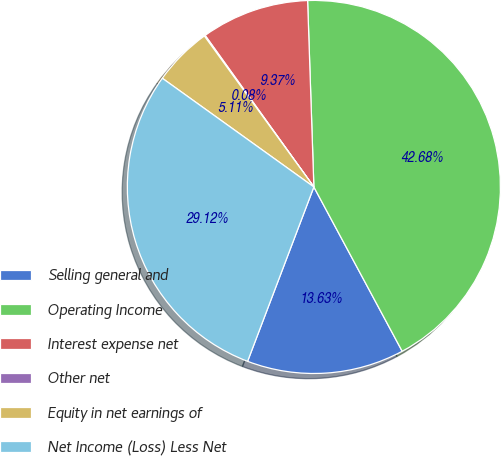Convert chart to OTSL. <chart><loc_0><loc_0><loc_500><loc_500><pie_chart><fcel>Selling general and<fcel>Operating Income<fcel>Interest expense net<fcel>Other net<fcel>Equity in net earnings of<fcel>Net Income (Loss) Less Net<nl><fcel>13.63%<fcel>42.68%<fcel>9.37%<fcel>0.08%<fcel>5.11%<fcel>29.12%<nl></chart> 